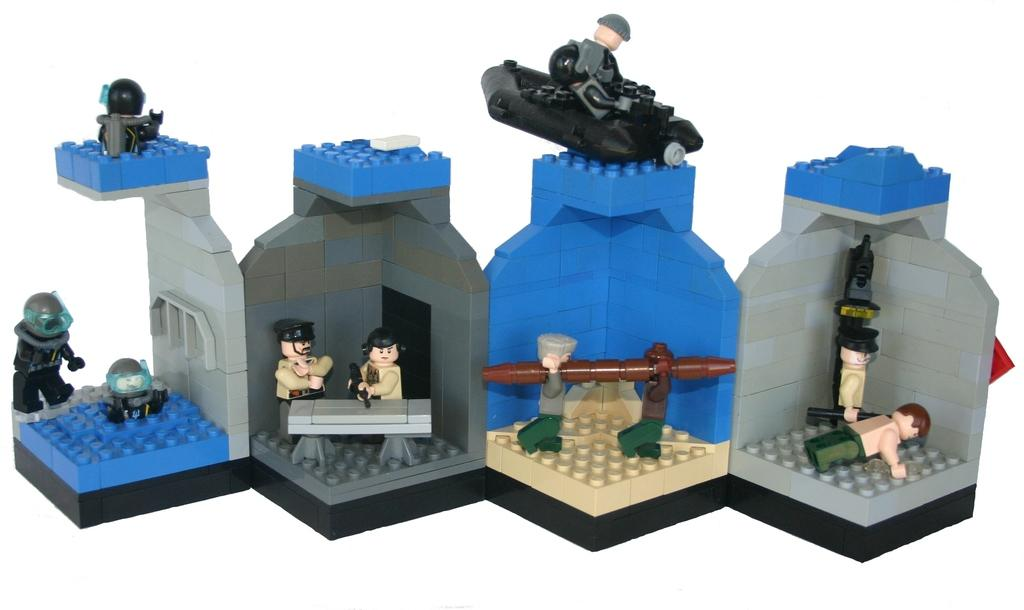What type of building materials are present in the image? There are lego boards in the image. What other items can be seen in the image? There are toys in the image. How much money is being exchanged between the men in the image? There are no men present in the image, and no money exchange is taking place. What type of fruit is being picked from the cherry tree in the image? There is no cherry tree or cherries present in the image. 